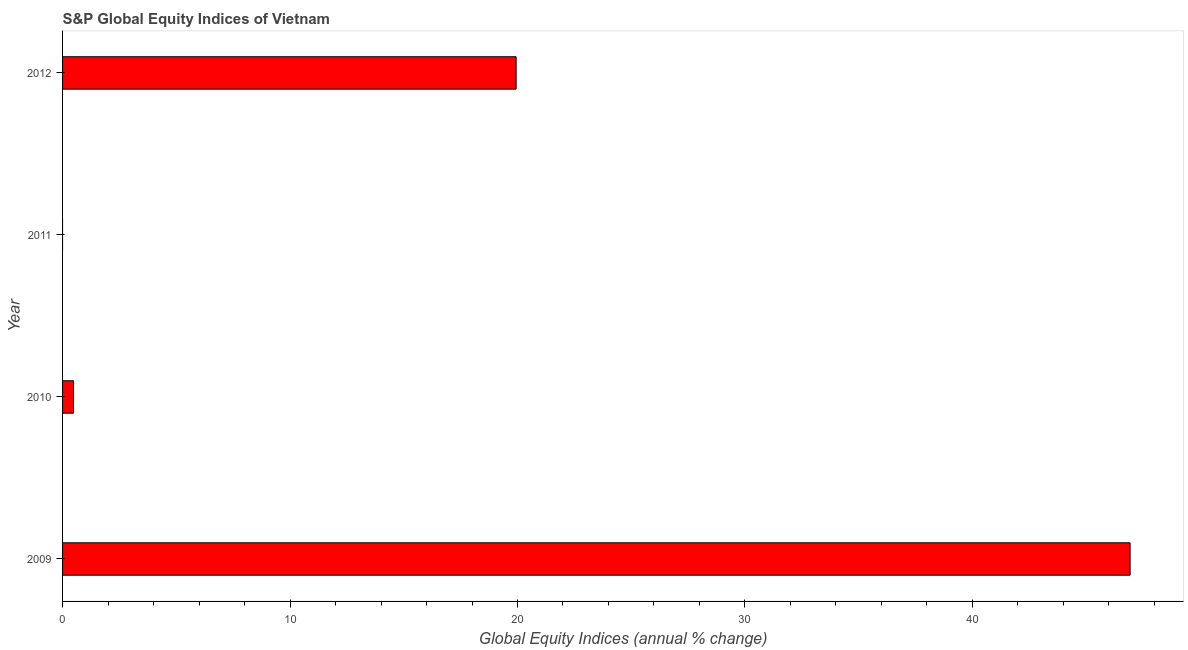Does the graph contain any zero values?
Your answer should be compact. Yes. Does the graph contain grids?
Give a very brief answer. No. What is the title of the graph?
Your answer should be very brief. S&P Global Equity Indices of Vietnam. What is the label or title of the X-axis?
Give a very brief answer. Global Equity Indices (annual % change). What is the label or title of the Y-axis?
Offer a very short reply. Year. What is the s&p global equity indices in 2012?
Keep it short and to the point. 19.94. Across all years, what is the maximum s&p global equity indices?
Provide a short and direct response. 46.93. Across all years, what is the minimum s&p global equity indices?
Offer a terse response. 0. What is the sum of the s&p global equity indices?
Ensure brevity in your answer.  67.35. What is the difference between the s&p global equity indices in 2009 and 2012?
Make the answer very short. 26.99. What is the average s&p global equity indices per year?
Your answer should be very brief. 16.84. What is the median s&p global equity indices?
Make the answer very short. 10.21. In how many years, is the s&p global equity indices greater than 20 %?
Offer a terse response. 1. What is the ratio of the s&p global equity indices in 2010 to that in 2012?
Your answer should be very brief. 0.02. Is the s&p global equity indices in 2010 less than that in 2012?
Offer a very short reply. Yes. Is the difference between the s&p global equity indices in 2010 and 2012 greater than the difference between any two years?
Provide a short and direct response. No. What is the difference between the highest and the second highest s&p global equity indices?
Your answer should be compact. 26.99. What is the difference between the highest and the lowest s&p global equity indices?
Offer a terse response. 46.93. How many bars are there?
Keep it short and to the point. 3. How many years are there in the graph?
Keep it short and to the point. 4. What is the difference between two consecutive major ticks on the X-axis?
Provide a succinct answer. 10. Are the values on the major ticks of X-axis written in scientific E-notation?
Keep it short and to the point. No. What is the Global Equity Indices (annual % change) of 2009?
Your answer should be compact. 46.93. What is the Global Equity Indices (annual % change) in 2010?
Provide a succinct answer. 0.48. What is the Global Equity Indices (annual % change) in 2012?
Your answer should be compact. 19.94. What is the difference between the Global Equity Indices (annual % change) in 2009 and 2010?
Your response must be concise. 46.45. What is the difference between the Global Equity Indices (annual % change) in 2009 and 2012?
Ensure brevity in your answer.  26.99. What is the difference between the Global Equity Indices (annual % change) in 2010 and 2012?
Provide a short and direct response. -19.46. What is the ratio of the Global Equity Indices (annual % change) in 2009 to that in 2010?
Give a very brief answer. 97.67. What is the ratio of the Global Equity Indices (annual % change) in 2009 to that in 2012?
Keep it short and to the point. 2.35. What is the ratio of the Global Equity Indices (annual % change) in 2010 to that in 2012?
Provide a succinct answer. 0.02. 